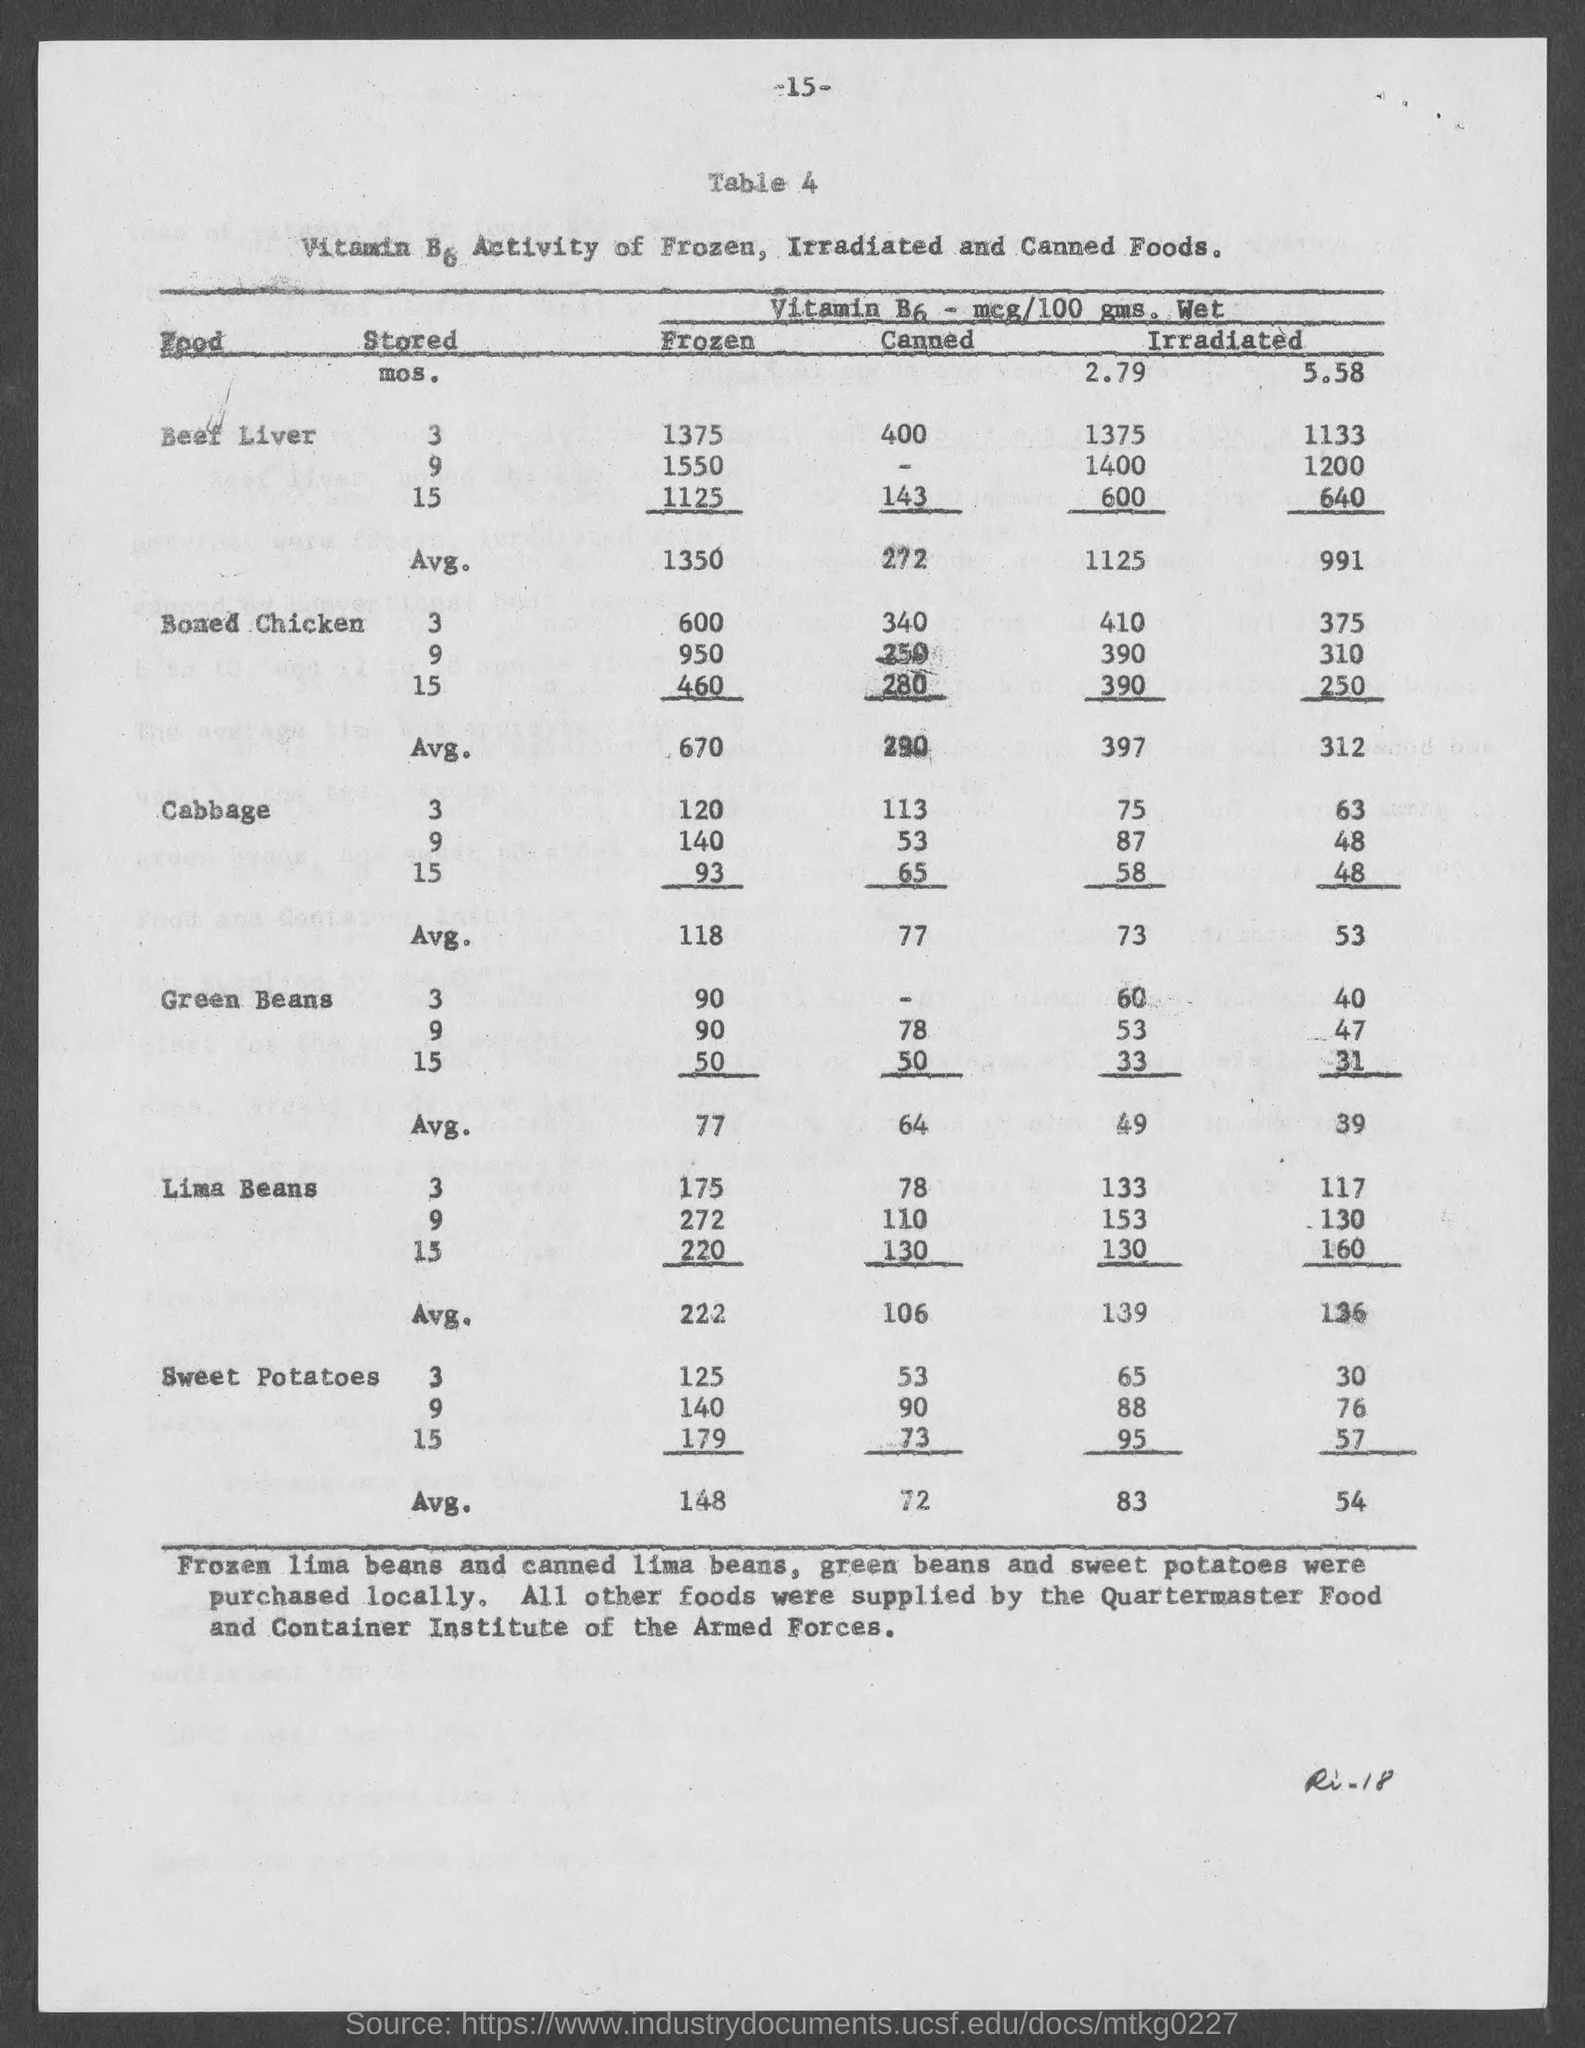Give some essential details in this illustration. The average of canned cabbage is 77. The average price of frozen beef liver is 1350. The average price of canned boneless chicken is approximately 290 USD. The average price of frozen boneless chicken is 670. The average of frozen cabbage is 118. 